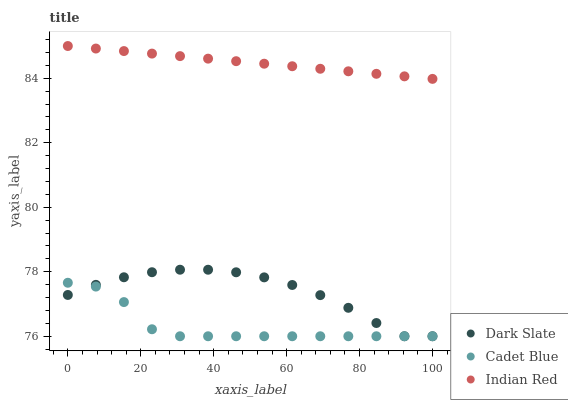Does Cadet Blue have the minimum area under the curve?
Answer yes or no. Yes. Does Indian Red have the maximum area under the curve?
Answer yes or no. Yes. Does Indian Red have the minimum area under the curve?
Answer yes or no. No. Does Cadet Blue have the maximum area under the curve?
Answer yes or no. No. Is Indian Red the smoothest?
Answer yes or no. Yes. Is Cadet Blue the roughest?
Answer yes or no. Yes. Is Cadet Blue the smoothest?
Answer yes or no. No. Is Indian Red the roughest?
Answer yes or no. No. Does Dark Slate have the lowest value?
Answer yes or no. Yes. Does Indian Red have the lowest value?
Answer yes or no. No. Does Indian Red have the highest value?
Answer yes or no. Yes. Does Cadet Blue have the highest value?
Answer yes or no. No. Is Dark Slate less than Indian Red?
Answer yes or no. Yes. Is Indian Red greater than Cadet Blue?
Answer yes or no. Yes. Does Cadet Blue intersect Dark Slate?
Answer yes or no. Yes. Is Cadet Blue less than Dark Slate?
Answer yes or no. No. Is Cadet Blue greater than Dark Slate?
Answer yes or no. No. Does Dark Slate intersect Indian Red?
Answer yes or no. No. 